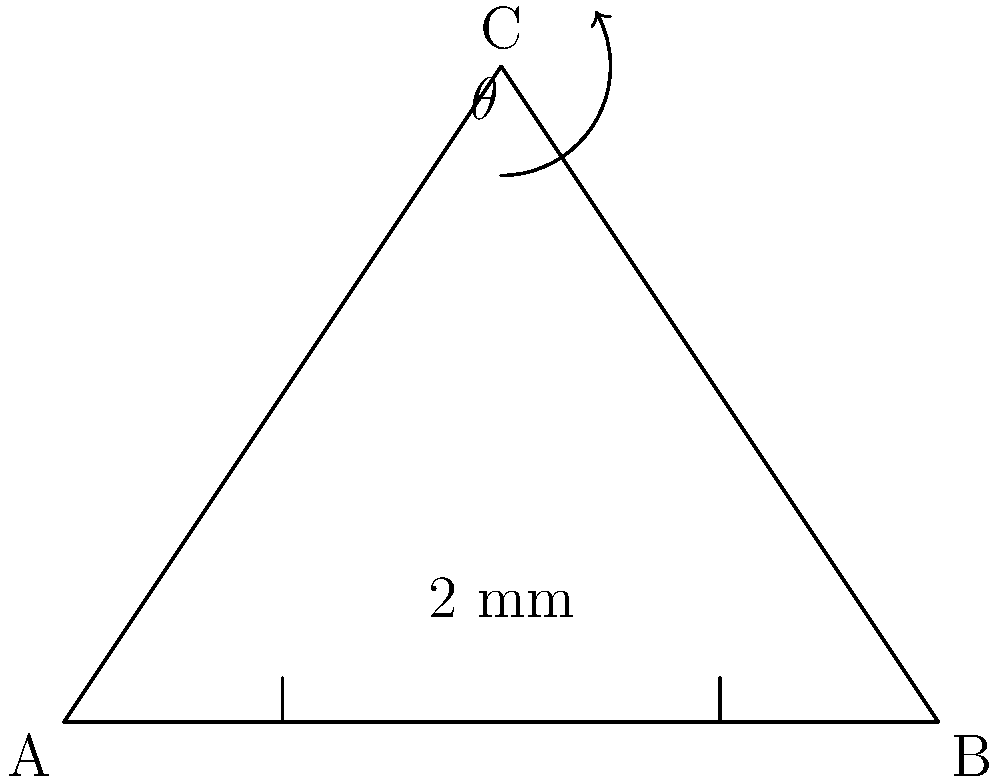In preparing a Class II cavity for a mandibular molar, you need to measure the angle between the buccal wall and the pulpal floor. Given that the buccal wall is represented by line AC and the pulpal floor by line AB in the diagram, with AB measuring 2 mm, what is the angle $\theta$ between these two surfaces? To find the angle $\theta$ between the buccal wall (AC) and the pulpal floor (AB), we can follow these steps:

1) First, we need to identify that we're dealing with a right-angled triangle. The pulpal floor (AB) forms the base, and the buccal wall (AC) forms the hypotenuse.

2) We're given that AB = 2 mm. We need to find the height of the triangle (BC) to use trigonometry.

3) In a right-angled triangle, we can use the Pythagorean theorem: $AC^2 = AB^2 + BC^2$

4) From the diagram, we can see that AC = 4 units and AB = 2 units.

5) Let's substitute these into the Pythagorean theorem:
   $4^2 = 2^2 + BC^2$
   $16 = 4 + BC^2$
   $BC^2 = 12$
   $BC = \sqrt{12} = 2\sqrt{3}$ units

6) Now we can use trigonometry to find $\theta$. In this case, we'll use the tangent function:

   $\tan(\theta) = \frac{\text{opposite}}{\text{adjacent}} = \frac{BC}{AB} = \frac{2\sqrt{3}}{2} = \sqrt{3}$

7) To find $\theta$, we take the inverse tangent (arctan or $\tan^{-1}$):

   $\theta = \tan^{-1}(\sqrt{3})$

8) This evaluates to approximately 60°.
Answer: 60° 